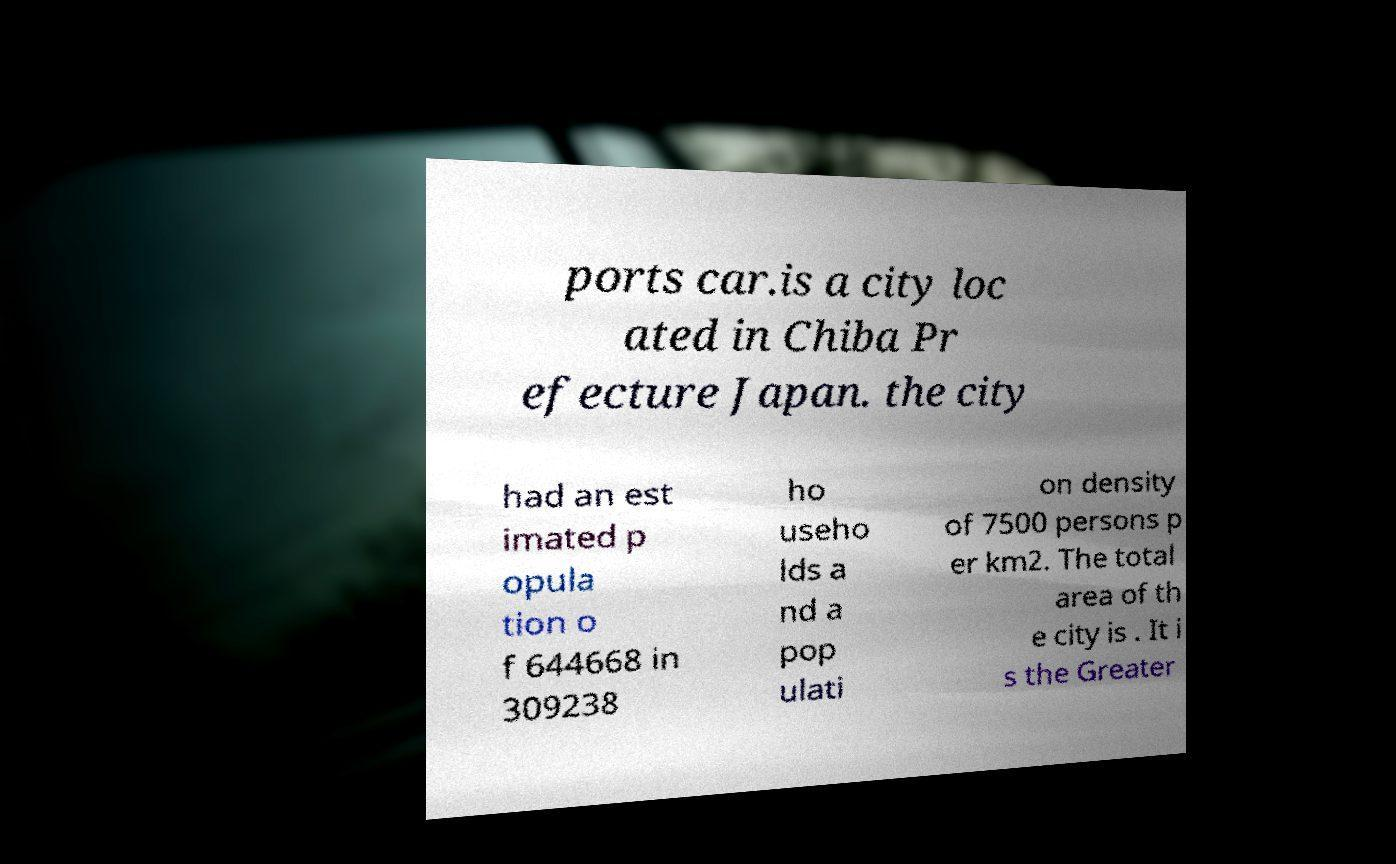I need the written content from this picture converted into text. Can you do that? ports car.is a city loc ated in Chiba Pr efecture Japan. the city had an est imated p opula tion o f 644668 in 309238 ho useho lds a nd a pop ulati on density of 7500 persons p er km2. The total area of th e city is . It i s the Greater 